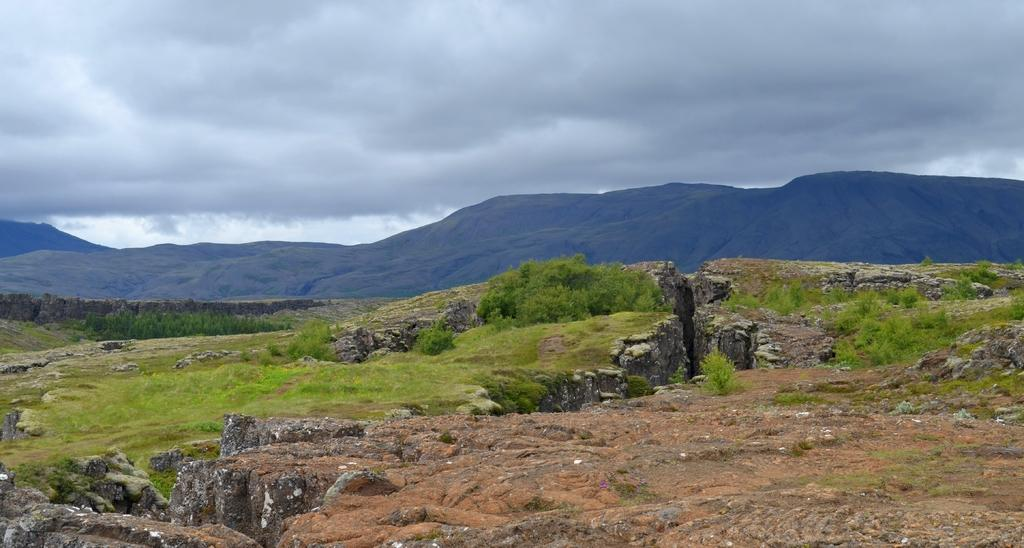What type of natural formation can be seen in the image? There are mountains in the image. What is visible at the bottom of the image? Grass and plants are visible at the bottom of the image. What is visible at the top of the image? The sky is visible at the top of the image. What can be seen in the sky in the image? Clouds are present in the sky. What type of beef is being served on the linen tablecloth in the image? There is no beef or linen tablecloth present in the image; it features mountains, grass and plants, the sky, and clouds. 